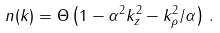<formula> <loc_0><loc_0><loc_500><loc_500>n ( k ) = \Theta \left ( 1 - \alpha ^ { 2 } k _ { z } ^ { 2 } - k _ { \rho } ^ { 2 } / \alpha \right ) \, .</formula> 